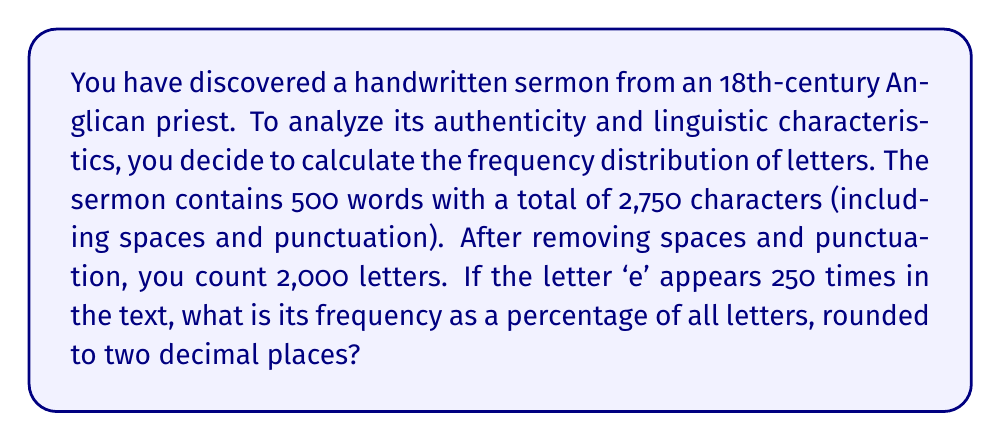What is the answer to this math problem? To solve this problem, we'll follow these steps:

1. Identify the total number of letters: 2,000

2. Identify the number of occurrences of the letter 'e': 250

3. Calculate the frequency as a percentage:
   Let $f$ be the frequency of 'e' as a percentage.
   
   $$f = \frac{\text{number of 'e' occurrences}}{\text{total number of letters}} \times 100\%$$

   $$f = \frac{250}{2000} \times 100\%$$

4. Simplify the fraction:
   $$f = \frac{1}{8} \times 100\%$$

5. Perform the calculation:
   $$f = 0.125 \times 100\% = 12.5\%$$

6. Round to two decimal places:
   The result is already in two decimal places, so no further rounding is needed.

Thus, the frequency of the letter 'e' in the sermon is 12.50% of all letters.
Answer: 12.50% 